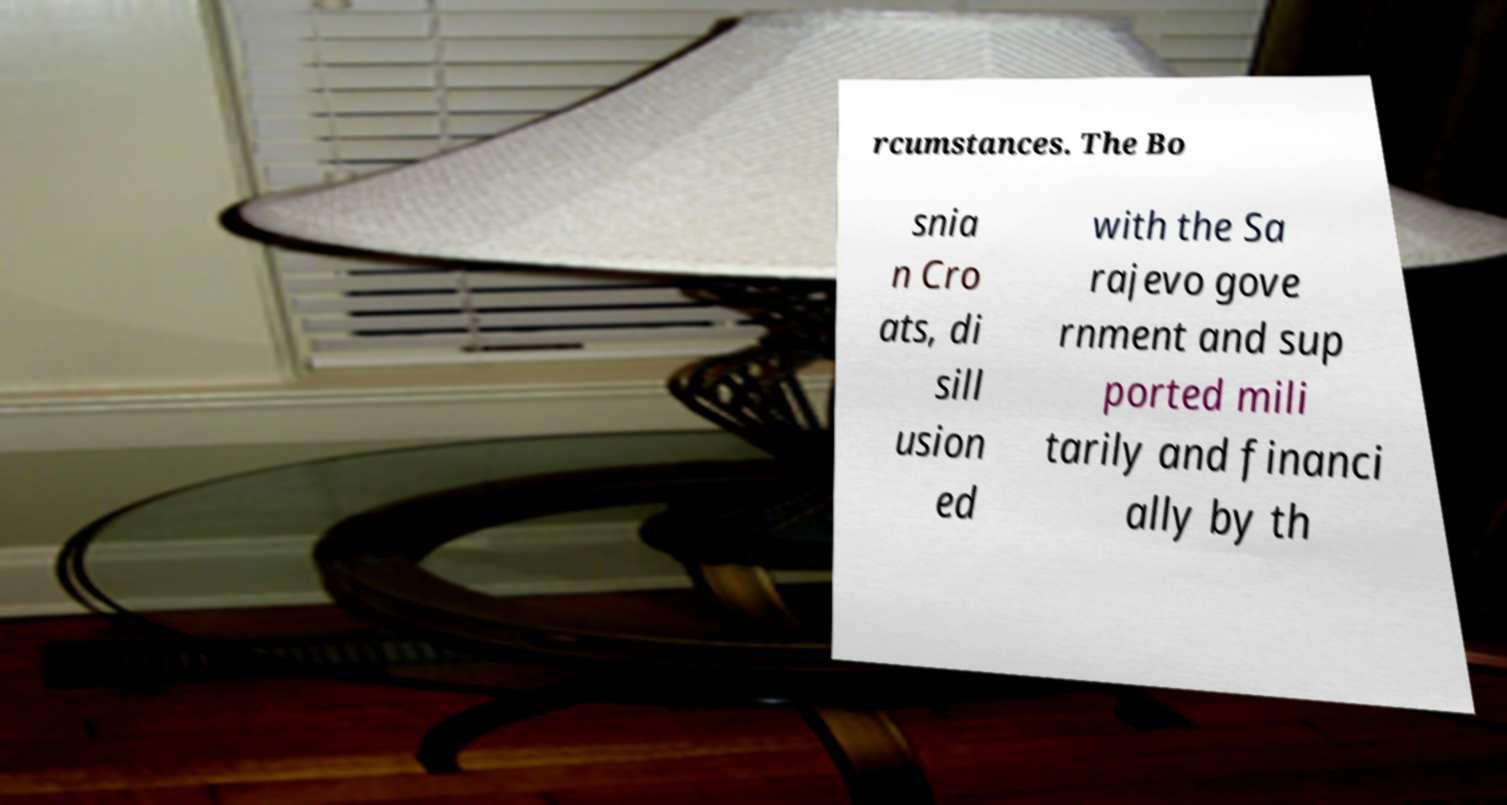Please read and relay the text visible in this image. What does it say? rcumstances. The Bo snia n Cro ats, di sill usion ed with the Sa rajevo gove rnment and sup ported mili tarily and financi ally by th 